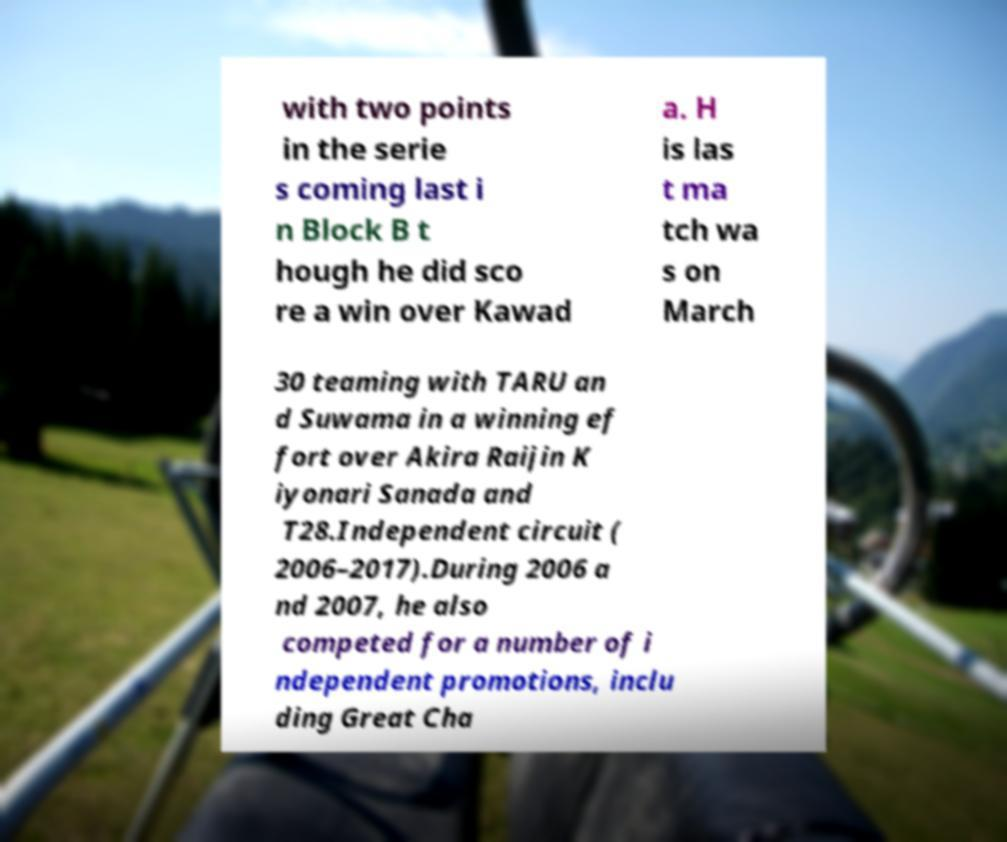Could you extract and type out the text from this image? with two points in the serie s coming last i n Block B t hough he did sco re a win over Kawad a. H is las t ma tch wa s on March 30 teaming with TARU an d Suwama in a winning ef fort over Akira Raijin K iyonari Sanada and T28.Independent circuit ( 2006–2017).During 2006 a nd 2007, he also competed for a number of i ndependent promotions, inclu ding Great Cha 